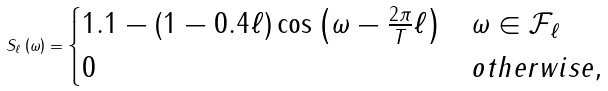<formula> <loc_0><loc_0><loc_500><loc_500>S _ { \ell } \left ( \omega \right ) = \begin{cases} 1 . 1 - \left ( 1 - 0 . 4 \ell \right ) \cos \left ( \omega - \frac { 2 \pi } { T } \ell \right ) & \omega \in \mathcal { F } _ { \ell } \\ 0 & o t h e r w i s e , \end{cases}</formula> 